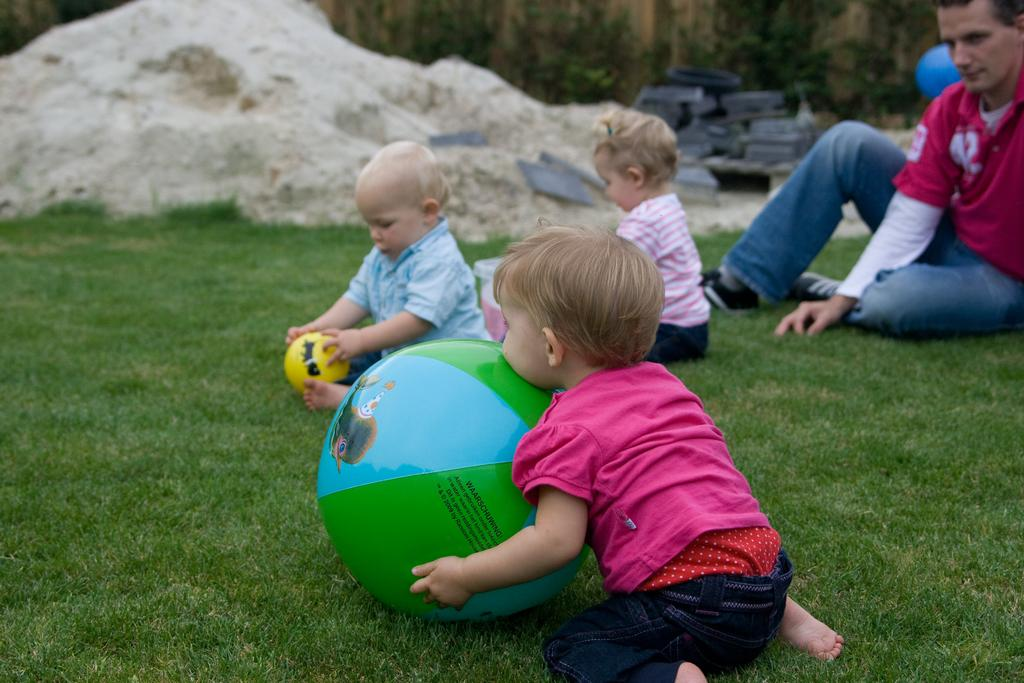What are the babies doing in the image? The babies are playing with a ball in the image. What can be seen in the background of the image? There is a person sitting in the garden and plants visible in the background of the image. What invention is being used by the lizards in the image? There are no lizards present in the image, so no invention is being used by them. 